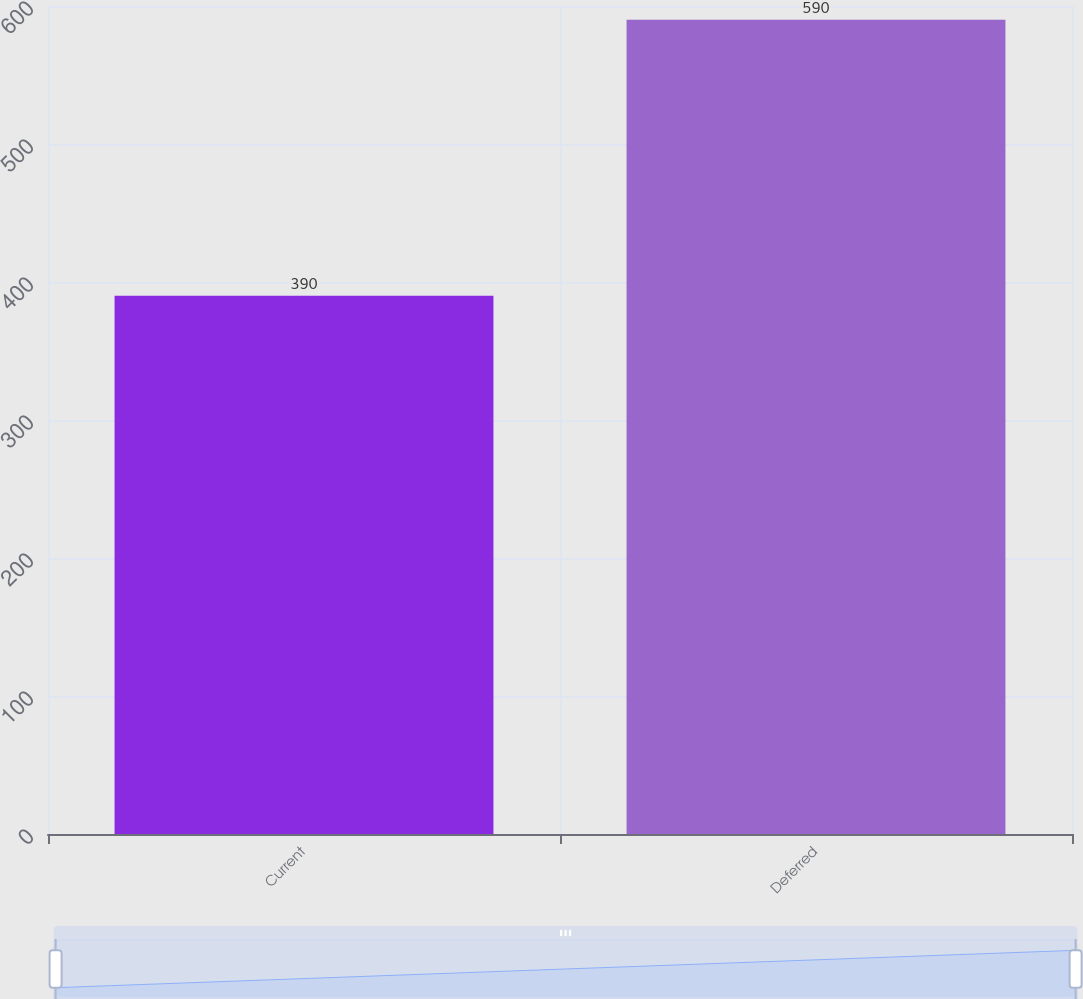Convert chart. <chart><loc_0><loc_0><loc_500><loc_500><bar_chart><fcel>Current<fcel>Deferred<nl><fcel>390<fcel>590<nl></chart> 